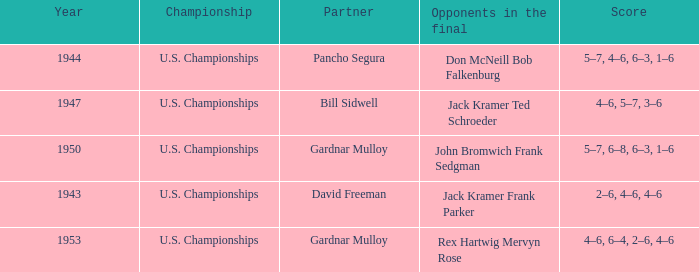Which Score has Opponents in the final of john bromwich frank sedgman? 5–7, 6–8, 6–3, 1–6. 